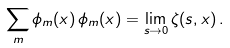Convert formula to latex. <formula><loc_0><loc_0><loc_500><loc_500>\sum _ { m } \phi _ { m } ( x ) \, \phi _ { m } ( x ) = \lim _ { s \rightarrow 0 } \zeta ( s , x ) \, .</formula> 